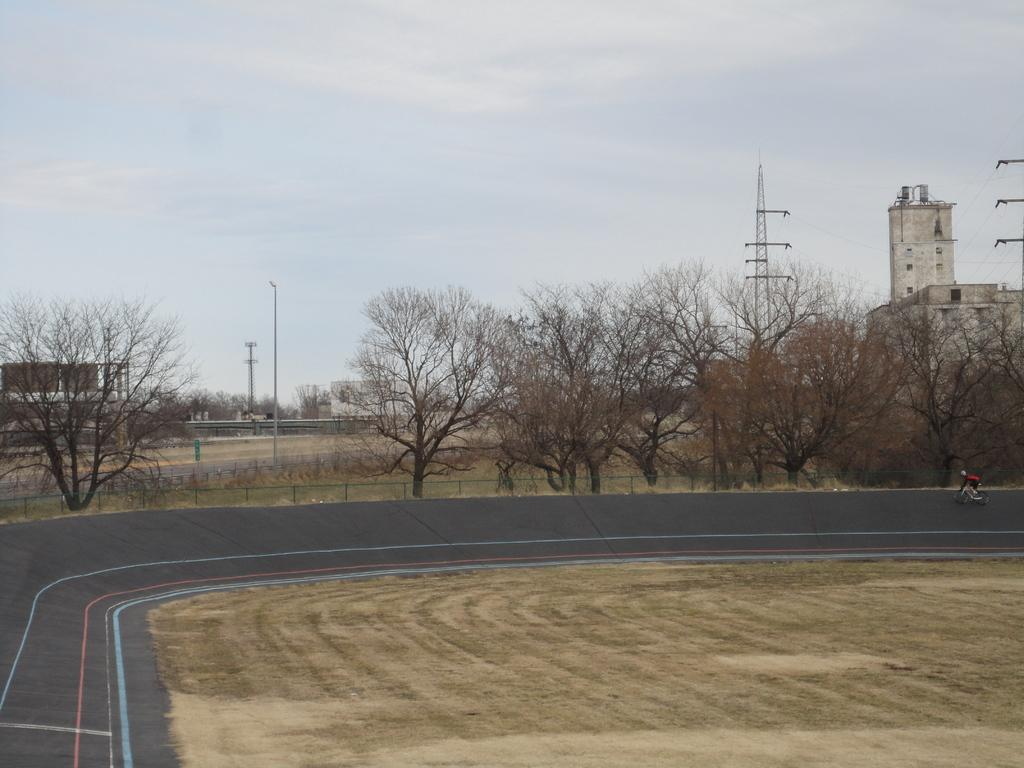What type of surface can be seen in the image? There is a road in the image. What natural elements are present in the image? There are trees and dry grass visible in the image. What man-made structures can be seen in the image? There are buildings, poles, and electric poles in the image. What is the weather like in the image? The sky is cloudy in the image. Who or what is present in the image? There is a person in the image. What is the person doing in the image? The person is riding a bicycle. What is the person wearing in the image? The person is wearing clothes. What type of engine is powering the bicycle in the image? The bicycle in the image does not have an engine; it is powered by the person riding it. What part of the person's body is injured in the image? There is no indication of an injury in the image; the person is riding a bicycle and appears to be in good health. 